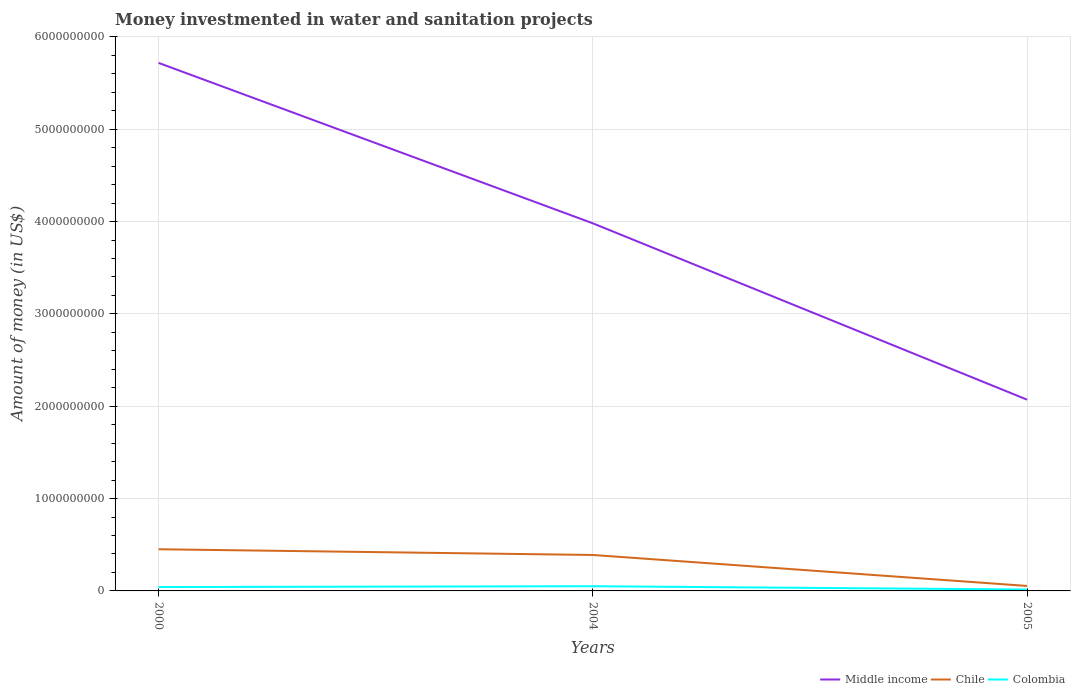Does the line corresponding to Colombia intersect with the line corresponding to Chile?
Give a very brief answer. No. Is the number of lines equal to the number of legend labels?
Keep it short and to the point. Yes. Across all years, what is the maximum money investmented in water and sanitation projects in Colombia?
Your answer should be compact. 1.53e+07. What is the total money investmented in water and sanitation projects in Middle income in the graph?
Provide a succinct answer. 3.65e+09. What is the difference between the highest and the second highest money investmented in water and sanitation projects in Colombia?
Provide a succinct answer. 3.57e+07. What is the difference between the highest and the lowest money investmented in water and sanitation projects in Middle income?
Offer a terse response. 2. Is the money investmented in water and sanitation projects in Chile strictly greater than the money investmented in water and sanitation projects in Colombia over the years?
Offer a very short reply. No. How many lines are there?
Keep it short and to the point. 3. Are the values on the major ticks of Y-axis written in scientific E-notation?
Offer a terse response. No. How are the legend labels stacked?
Ensure brevity in your answer.  Horizontal. What is the title of the graph?
Give a very brief answer. Money investmented in water and sanitation projects. What is the label or title of the Y-axis?
Keep it short and to the point. Amount of money (in US$). What is the Amount of money (in US$) of Middle income in 2000?
Your answer should be very brief. 5.72e+09. What is the Amount of money (in US$) in Chile in 2000?
Provide a succinct answer. 4.51e+08. What is the Amount of money (in US$) in Colombia in 2000?
Keep it short and to the point. 4.20e+07. What is the Amount of money (in US$) in Middle income in 2004?
Provide a short and direct response. 3.98e+09. What is the Amount of money (in US$) in Chile in 2004?
Your answer should be compact. 3.89e+08. What is the Amount of money (in US$) in Colombia in 2004?
Provide a short and direct response. 5.10e+07. What is the Amount of money (in US$) in Middle income in 2005?
Offer a very short reply. 2.07e+09. What is the Amount of money (in US$) in Chile in 2005?
Ensure brevity in your answer.  5.40e+07. What is the Amount of money (in US$) in Colombia in 2005?
Give a very brief answer. 1.53e+07. Across all years, what is the maximum Amount of money (in US$) of Middle income?
Your answer should be very brief. 5.72e+09. Across all years, what is the maximum Amount of money (in US$) of Chile?
Provide a succinct answer. 4.51e+08. Across all years, what is the maximum Amount of money (in US$) in Colombia?
Ensure brevity in your answer.  5.10e+07. Across all years, what is the minimum Amount of money (in US$) of Middle income?
Your response must be concise. 2.07e+09. Across all years, what is the minimum Amount of money (in US$) in Chile?
Ensure brevity in your answer.  5.40e+07. Across all years, what is the minimum Amount of money (in US$) of Colombia?
Offer a terse response. 1.53e+07. What is the total Amount of money (in US$) in Middle income in the graph?
Your response must be concise. 1.18e+1. What is the total Amount of money (in US$) in Chile in the graph?
Your answer should be very brief. 8.95e+08. What is the total Amount of money (in US$) of Colombia in the graph?
Offer a very short reply. 1.08e+08. What is the difference between the Amount of money (in US$) of Middle income in 2000 and that in 2004?
Make the answer very short. 1.74e+09. What is the difference between the Amount of money (in US$) in Chile in 2000 and that in 2004?
Keep it short and to the point. 6.19e+07. What is the difference between the Amount of money (in US$) of Colombia in 2000 and that in 2004?
Offer a very short reply. -9.00e+06. What is the difference between the Amount of money (in US$) of Middle income in 2000 and that in 2005?
Keep it short and to the point. 3.65e+09. What is the difference between the Amount of money (in US$) of Chile in 2000 and that in 2005?
Offer a very short reply. 3.97e+08. What is the difference between the Amount of money (in US$) in Colombia in 2000 and that in 2005?
Keep it short and to the point. 2.67e+07. What is the difference between the Amount of money (in US$) in Middle income in 2004 and that in 2005?
Ensure brevity in your answer.  1.91e+09. What is the difference between the Amount of money (in US$) of Chile in 2004 and that in 2005?
Your answer should be compact. 3.35e+08. What is the difference between the Amount of money (in US$) of Colombia in 2004 and that in 2005?
Make the answer very short. 3.57e+07. What is the difference between the Amount of money (in US$) of Middle income in 2000 and the Amount of money (in US$) of Chile in 2004?
Offer a very short reply. 5.33e+09. What is the difference between the Amount of money (in US$) in Middle income in 2000 and the Amount of money (in US$) in Colombia in 2004?
Give a very brief answer. 5.67e+09. What is the difference between the Amount of money (in US$) of Chile in 2000 and the Amount of money (in US$) of Colombia in 2004?
Your response must be concise. 4.00e+08. What is the difference between the Amount of money (in US$) in Middle income in 2000 and the Amount of money (in US$) in Chile in 2005?
Your answer should be very brief. 5.66e+09. What is the difference between the Amount of money (in US$) in Middle income in 2000 and the Amount of money (in US$) in Colombia in 2005?
Your answer should be compact. 5.70e+09. What is the difference between the Amount of money (in US$) of Chile in 2000 and the Amount of money (in US$) of Colombia in 2005?
Give a very brief answer. 4.36e+08. What is the difference between the Amount of money (in US$) in Middle income in 2004 and the Amount of money (in US$) in Chile in 2005?
Your answer should be very brief. 3.93e+09. What is the difference between the Amount of money (in US$) of Middle income in 2004 and the Amount of money (in US$) of Colombia in 2005?
Give a very brief answer. 3.97e+09. What is the difference between the Amount of money (in US$) in Chile in 2004 and the Amount of money (in US$) in Colombia in 2005?
Ensure brevity in your answer.  3.74e+08. What is the average Amount of money (in US$) of Middle income per year?
Ensure brevity in your answer.  3.92e+09. What is the average Amount of money (in US$) in Chile per year?
Offer a terse response. 2.98e+08. What is the average Amount of money (in US$) in Colombia per year?
Your answer should be very brief. 3.61e+07. In the year 2000, what is the difference between the Amount of money (in US$) of Middle income and Amount of money (in US$) of Chile?
Provide a short and direct response. 5.27e+09. In the year 2000, what is the difference between the Amount of money (in US$) of Middle income and Amount of money (in US$) of Colombia?
Keep it short and to the point. 5.68e+09. In the year 2000, what is the difference between the Amount of money (in US$) of Chile and Amount of money (in US$) of Colombia?
Ensure brevity in your answer.  4.09e+08. In the year 2004, what is the difference between the Amount of money (in US$) in Middle income and Amount of money (in US$) in Chile?
Ensure brevity in your answer.  3.59e+09. In the year 2004, what is the difference between the Amount of money (in US$) in Middle income and Amount of money (in US$) in Colombia?
Make the answer very short. 3.93e+09. In the year 2004, what is the difference between the Amount of money (in US$) in Chile and Amount of money (in US$) in Colombia?
Make the answer very short. 3.38e+08. In the year 2005, what is the difference between the Amount of money (in US$) in Middle income and Amount of money (in US$) in Chile?
Make the answer very short. 2.02e+09. In the year 2005, what is the difference between the Amount of money (in US$) of Middle income and Amount of money (in US$) of Colombia?
Make the answer very short. 2.06e+09. In the year 2005, what is the difference between the Amount of money (in US$) of Chile and Amount of money (in US$) of Colombia?
Offer a terse response. 3.87e+07. What is the ratio of the Amount of money (in US$) of Middle income in 2000 to that in 2004?
Provide a short and direct response. 1.44. What is the ratio of the Amount of money (in US$) of Chile in 2000 to that in 2004?
Make the answer very short. 1.16. What is the ratio of the Amount of money (in US$) of Colombia in 2000 to that in 2004?
Make the answer very short. 0.82. What is the ratio of the Amount of money (in US$) in Middle income in 2000 to that in 2005?
Your answer should be very brief. 2.76. What is the ratio of the Amount of money (in US$) in Chile in 2000 to that in 2005?
Offer a terse response. 8.36. What is the ratio of the Amount of money (in US$) in Colombia in 2000 to that in 2005?
Give a very brief answer. 2.75. What is the ratio of the Amount of money (in US$) in Middle income in 2004 to that in 2005?
Your answer should be compact. 1.92. What is the ratio of the Amount of money (in US$) of Chile in 2004 to that in 2005?
Give a very brief answer. 7.21. What is the ratio of the Amount of money (in US$) of Colombia in 2004 to that in 2005?
Offer a very short reply. 3.34. What is the difference between the highest and the second highest Amount of money (in US$) of Middle income?
Give a very brief answer. 1.74e+09. What is the difference between the highest and the second highest Amount of money (in US$) of Chile?
Offer a very short reply. 6.19e+07. What is the difference between the highest and the second highest Amount of money (in US$) of Colombia?
Offer a terse response. 9.00e+06. What is the difference between the highest and the lowest Amount of money (in US$) of Middle income?
Ensure brevity in your answer.  3.65e+09. What is the difference between the highest and the lowest Amount of money (in US$) of Chile?
Keep it short and to the point. 3.97e+08. What is the difference between the highest and the lowest Amount of money (in US$) in Colombia?
Offer a terse response. 3.57e+07. 